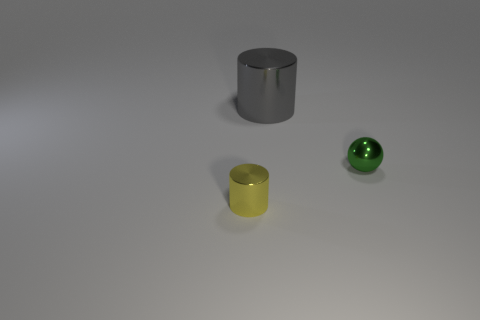Add 3 small green cylinders. How many objects exist? 6 Subtract 0 yellow blocks. How many objects are left? 3 Subtract all spheres. How many objects are left? 2 Subtract 2 cylinders. How many cylinders are left? 0 Subtract all red spheres. Subtract all brown blocks. How many spheres are left? 1 Subtract all green blocks. How many gray cylinders are left? 1 Subtract all tiny yellow metallic cylinders. Subtract all cylinders. How many objects are left? 0 Add 3 big gray cylinders. How many big gray cylinders are left? 4 Add 2 gray cylinders. How many gray cylinders exist? 3 Subtract all yellow cylinders. How many cylinders are left? 1 